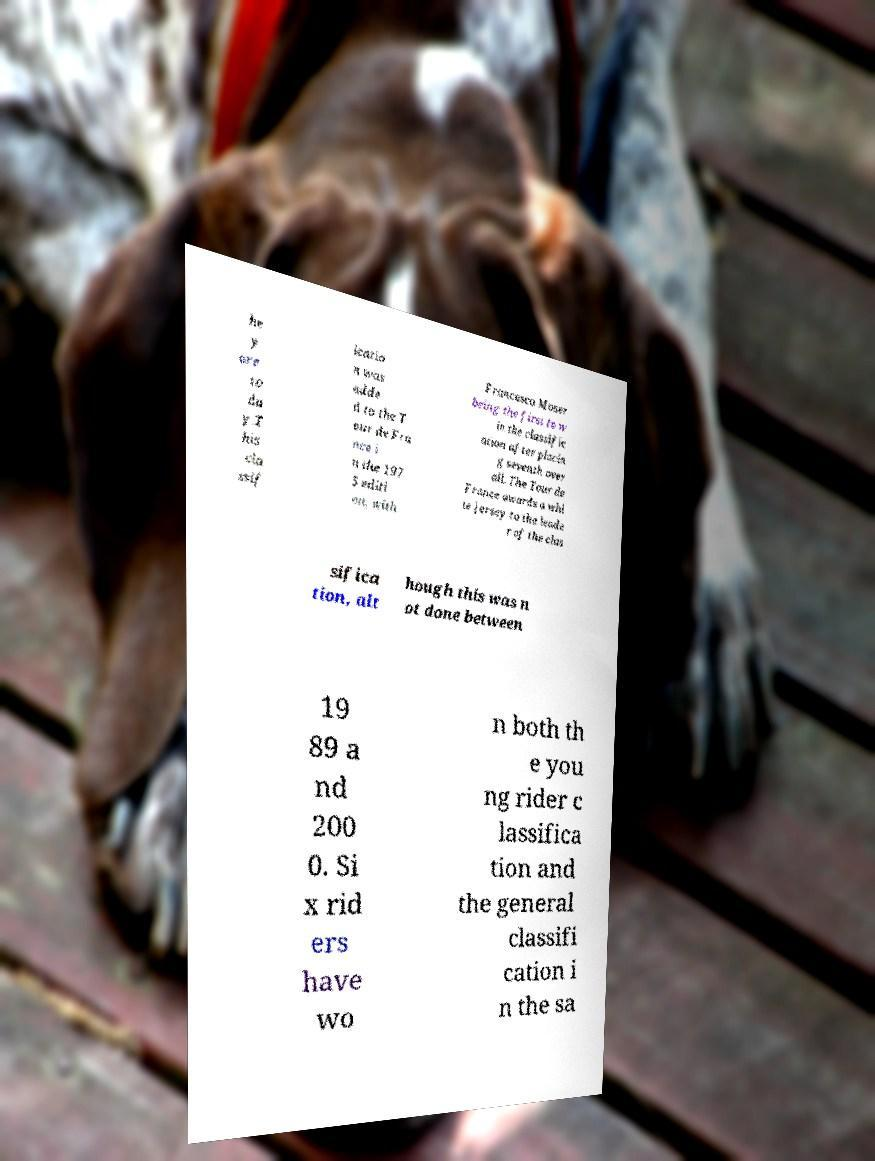Please identify and transcribe the text found in this image. he y are to da y.T his cla ssif icatio n was adde d to the T our de Fra nce i n the 197 5 editi on, with Francesco Moser being the first to w in the classific ation after placin g seventh over all. The Tour de France awards a whi te jersey to the leade r of the clas sifica tion, alt hough this was n ot done between 19 89 a nd 200 0. Si x rid ers have wo n both th e you ng rider c lassifica tion and the general classifi cation i n the sa 